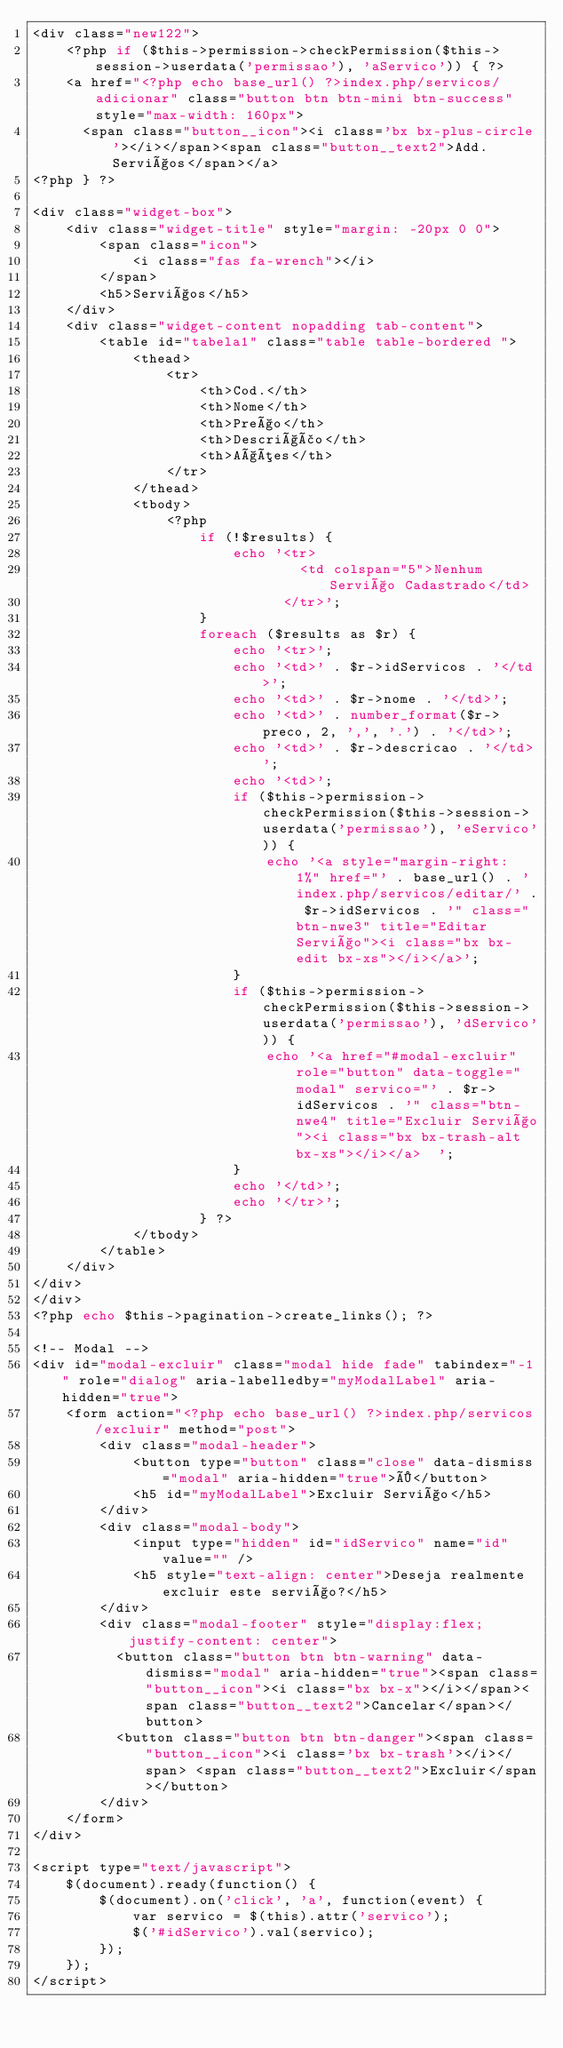Convert code to text. <code><loc_0><loc_0><loc_500><loc_500><_PHP_><div class="new122">
    <?php if ($this->permission->checkPermission($this->session->userdata('permissao'), 'aServico')) { ?>
    <a href="<?php echo base_url() ?>index.php/servicos/adicionar" class="button btn btn-mini btn-success" style="max-width: 160px">
      <span class="button__icon"><i class='bx bx-plus-circle'></i></span><span class="button__text2">Add. Serviços</span></a>
<?php } ?>

<div class="widget-box">
    <div class="widget-title" style="margin: -20px 0 0">
        <span class="icon">
            <i class="fas fa-wrench"></i>
        </span>
        <h5>Serviços</h5>
    </div>
    <div class="widget-content nopadding tab-content">
        <table id="tabela1" class="table table-bordered ">
            <thead>
                <tr>
                    <th>Cod.</th>
                    <th>Nome</th>
                    <th>Preço</th>
                    <th>Descrição</th>
                    <th>Ações</th>
                </tr>
            </thead>
            <tbody>
                <?php
                    if (!$results) {
                        echo '<tr>
                                <td colspan="5">Nenhum Serviço Cadastrado</td>
                              </tr>';
                    }
                    foreach ($results as $r) {
                        echo '<tr>';
                        echo '<td>' . $r->idServicos . '</td>';
                        echo '<td>' . $r->nome . '</td>';
                        echo '<td>' . number_format($r->preco, 2, ',', '.') . '</td>';
                        echo '<td>' . $r->descricao . '</td>';
                        echo '<td>';
                        if ($this->permission->checkPermission($this->session->userdata('permissao'), 'eServico')) {
                            echo '<a style="margin-right: 1%" href="' . base_url() . 'index.php/servicos/editar/' . $r->idServicos . '" class="btn-nwe3" title="Editar Serviço"><i class="bx bx-edit bx-xs"></i></a>';
                        }
                        if ($this->permission->checkPermission($this->session->userdata('permissao'), 'dServico')) {
                            echo '<a href="#modal-excluir" role="button" data-toggle="modal" servico="' . $r->idServicos . '" class="btn-nwe4" title="Excluir Serviço"><i class="bx bx-trash-alt bx-xs"></i></a>  ';
                        }
                        echo '</td>';
                        echo '</tr>';
                    } ?>
            </tbody>
        </table>
    </div>
</div>
</div>
<?php echo $this->pagination->create_links(); ?>

<!-- Modal -->
<div id="modal-excluir" class="modal hide fade" tabindex="-1" role="dialog" aria-labelledby="myModalLabel" aria-hidden="true">
    <form action="<?php echo base_url() ?>index.php/servicos/excluir" method="post">
        <div class="modal-header">
            <button type="button" class="close" data-dismiss="modal" aria-hidden="true">×</button>
            <h5 id="myModalLabel">Excluir Serviço</h5>
        </div>
        <div class="modal-body">
            <input type="hidden" id="idServico" name="id" value="" />
            <h5 style="text-align: center">Deseja realmente excluir este serviço?</h5>
        </div>
        <div class="modal-footer" style="display:flex;justify-content: center">
          <button class="button btn btn-warning" data-dismiss="modal" aria-hidden="true"><span class="button__icon"><i class="bx bx-x"></i></span><span class="button__text2">Cancelar</span></button>
          <button class="button btn btn-danger"><span class="button__icon"><i class='bx bx-trash'></i></span> <span class="button__text2">Excluir</span></button>
        </div>
    </form>
</div>

<script type="text/javascript">
    $(document).ready(function() {
        $(document).on('click', 'a', function(event) {
            var servico = $(this).attr('servico');
            $('#idServico').val(servico);
        });
    });
</script>
</code> 